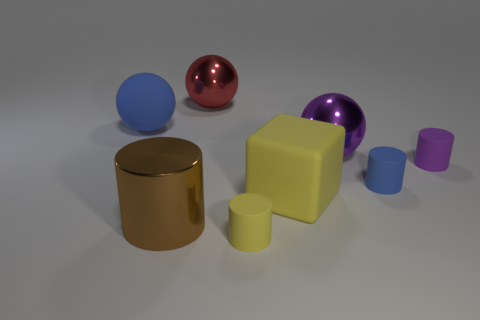Subtract all big metal spheres. How many spheres are left? 1 Subtract 1 balls. How many balls are left? 2 Subtract all blue cylinders. How many cylinders are left? 3 Subtract all red cylinders. Subtract all blue cubes. How many cylinders are left? 4 Add 1 big blocks. How many objects exist? 9 Subtract all blocks. How many objects are left? 7 Add 8 cyan matte cylinders. How many cyan matte cylinders exist? 8 Subtract 1 red balls. How many objects are left? 7 Subtract all large blue matte things. Subtract all yellow objects. How many objects are left? 5 Add 3 metallic things. How many metallic things are left? 6 